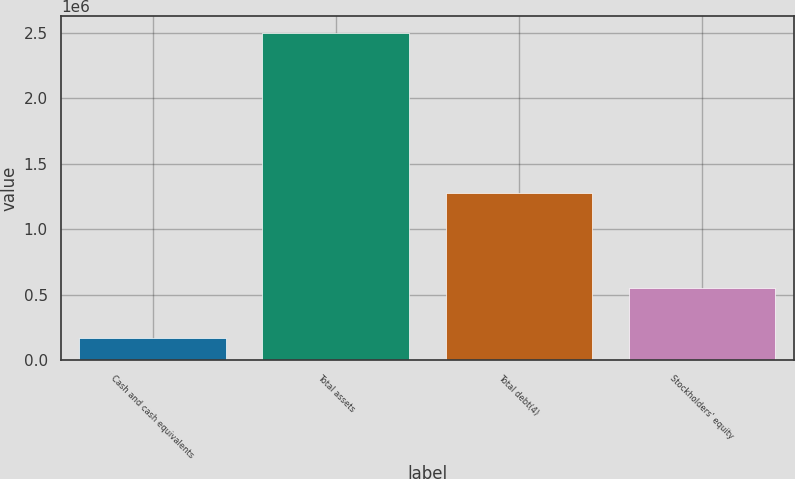Convert chart to OTSL. <chart><loc_0><loc_0><loc_500><loc_500><bar_chart><fcel>Cash and cash equivalents<fcel>Total assets<fcel>Total debt(4)<fcel>Stockholders' equity<nl><fcel>165801<fcel>2.50445e+06<fcel>1.27589e+06<fcel>547589<nl></chart> 